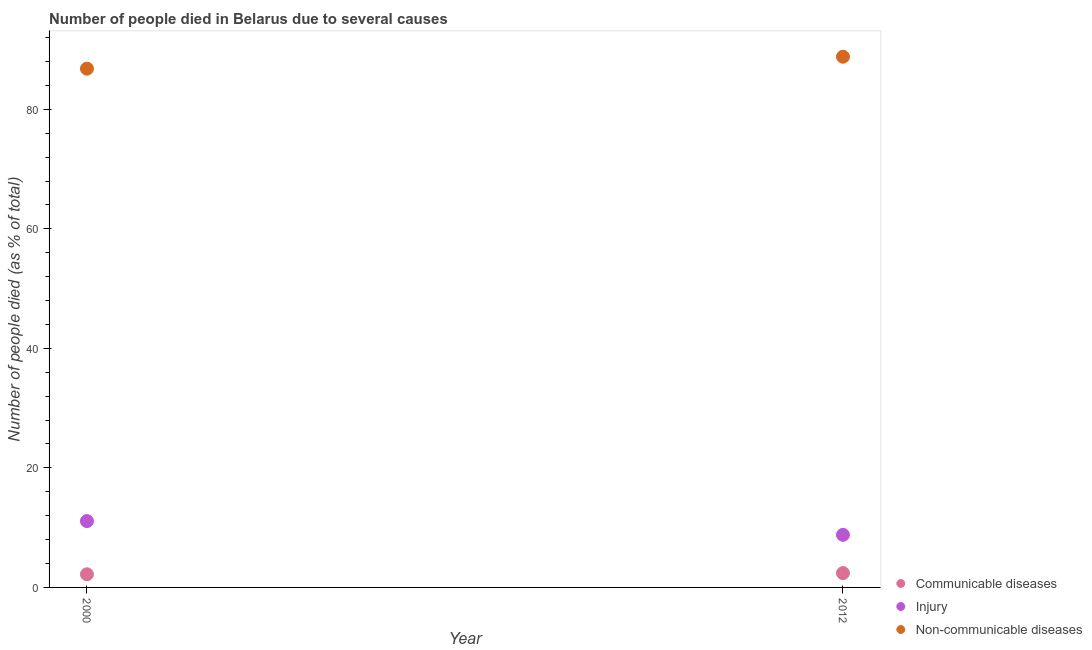How many different coloured dotlines are there?
Your answer should be compact. 3. Is the number of dotlines equal to the number of legend labels?
Provide a short and direct response. Yes. Across all years, what is the maximum number of people who dies of non-communicable diseases?
Offer a very short reply. 88.8. What is the difference between the number of people who died of communicable diseases in 2000 and that in 2012?
Provide a succinct answer. -0.2. What is the difference between the number of people who died of injury in 2012 and the number of people who died of communicable diseases in 2000?
Keep it short and to the point. 6.6. What is the average number of people who died of injury per year?
Your answer should be very brief. 9.95. In the year 2000, what is the difference between the number of people who dies of non-communicable diseases and number of people who died of injury?
Offer a terse response. 75.7. What is the ratio of the number of people who died of injury in 2000 to that in 2012?
Offer a very short reply. 1.26. Is the number of people who died of injury in 2000 less than that in 2012?
Ensure brevity in your answer.  No. Is the number of people who died of communicable diseases strictly greater than the number of people who dies of non-communicable diseases over the years?
Your response must be concise. No. Is the number of people who died of injury strictly less than the number of people who dies of non-communicable diseases over the years?
Give a very brief answer. Yes. How many dotlines are there?
Provide a succinct answer. 3. How many years are there in the graph?
Offer a terse response. 2. What is the difference between two consecutive major ticks on the Y-axis?
Your answer should be very brief. 20. Where does the legend appear in the graph?
Provide a short and direct response. Bottom right. How are the legend labels stacked?
Provide a short and direct response. Vertical. What is the title of the graph?
Provide a succinct answer. Number of people died in Belarus due to several causes. Does "Oil sources" appear as one of the legend labels in the graph?
Offer a terse response. No. What is the label or title of the X-axis?
Provide a succinct answer. Year. What is the label or title of the Y-axis?
Keep it short and to the point. Number of people died (as % of total). What is the Number of people died (as % of total) of Injury in 2000?
Offer a very short reply. 11.1. What is the Number of people died (as % of total) in Non-communicable diseases in 2000?
Provide a short and direct response. 86.8. What is the Number of people died (as % of total) in Communicable diseases in 2012?
Your response must be concise. 2.4. What is the Number of people died (as % of total) in Non-communicable diseases in 2012?
Offer a terse response. 88.8. Across all years, what is the maximum Number of people died (as % of total) in Non-communicable diseases?
Keep it short and to the point. 88.8. Across all years, what is the minimum Number of people died (as % of total) in Injury?
Offer a very short reply. 8.8. Across all years, what is the minimum Number of people died (as % of total) of Non-communicable diseases?
Give a very brief answer. 86.8. What is the total Number of people died (as % of total) of Injury in the graph?
Provide a succinct answer. 19.9. What is the total Number of people died (as % of total) of Non-communicable diseases in the graph?
Offer a very short reply. 175.6. What is the difference between the Number of people died (as % of total) of Injury in 2000 and that in 2012?
Provide a short and direct response. 2.3. What is the difference between the Number of people died (as % of total) of Communicable diseases in 2000 and the Number of people died (as % of total) of Non-communicable diseases in 2012?
Make the answer very short. -86.6. What is the difference between the Number of people died (as % of total) of Injury in 2000 and the Number of people died (as % of total) of Non-communicable diseases in 2012?
Offer a terse response. -77.7. What is the average Number of people died (as % of total) in Communicable diseases per year?
Make the answer very short. 2.3. What is the average Number of people died (as % of total) in Injury per year?
Give a very brief answer. 9.95. What is the average Number of people died (as % of total) in Non-communicable diseases per year?
Provide a short and direct response. 87.8. In the year 2000, what is the difference between the Number of people died (as % of total) in Communicable diseases and Number of people died (as % of total) in Non-communicable diseases?
Offer a terse response. -84.6. In the year 2000, what is the difference between the Number of people died (as % of total) in Injury and Number of people died (as % of total) in Non-communicable diseases?
Keep it short and to the point. -75.7. In the year 2012, what is the difference between the Number of people died (as % of total) of Communicable diseases and Number of people died (as % of total) of Injury?
Give a very brief answer. -6.4. In the year 2012, what is the difference between the Number of people died (as % of total) in Communicable diseases and Number of people died (as % of total) in Non-communicable diseases?
Make the answer very short. -86.4. In the year 2012, what is the difference between the Number of people died (as % of total) of Injury and Number of people died (as % of total) of Non-communicable diseases?
Your answer should be compact. -80. What is the ratio of the Number of people died (as % of total) of Communicable diseases in 2000 to that in 2012?
Give a very brief answer. 0.92. What is the ratio of the Number of people died (as % of total) of Injury in 2000 to that in 2012?
Your response must be concise. 1.26. What is the ratio of the Number of people died (as % of total) in Non-communicable diseases in 2000 to that in 2012?
Keep it short and to the point. 0.98. What is the difference between the highest and the second highest Number of people died (as % of total) of Communicable diseases?
Keep it short and to the point. 0.2. What is the difference between the highest and the second highest Number of people died (as % of total) of Non-communicable diseases?
Offer a very short reply. 2. What is the difference between the highest and the lowest Number of people died (as % of total) in Non-communicable diseases?
Your response must be concise. 2. 